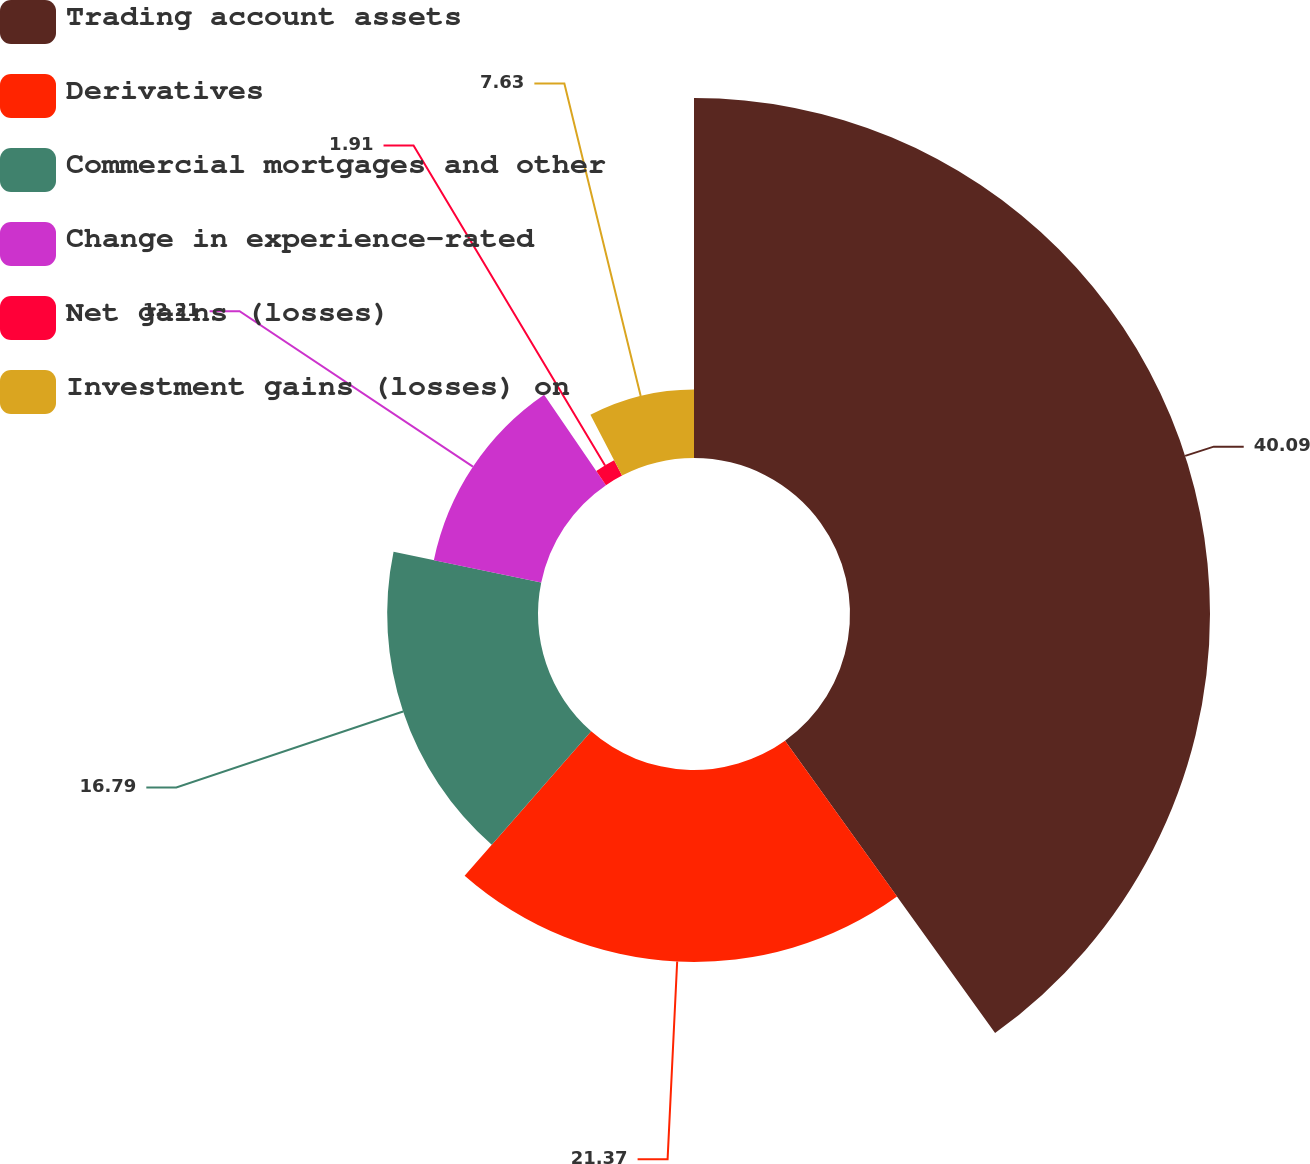Convert chart. <chart><loc_0><loc_0><loc_500><loc_500><pie_chart><fcel>Trading account assets<fcel>Derivatives<fcel>Commercial mortgages and other<fcel>Change in experience-rated<fcel>Net gains (losses)<fcel>Investment gains (losses) on<nl><fcel>40.08%<fcel>21.37%<fcel>16.79%<fcel>12.21%<fcel>1.91%<fcel>7.63%<nl></chart> 